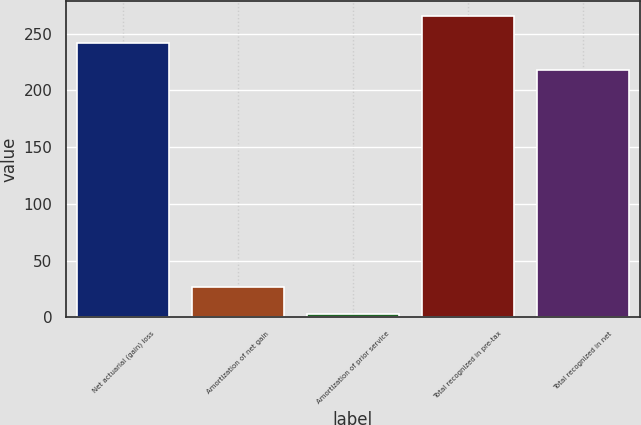<chart> <loc_0><loc_0><loc_500><loc_500><bar_chart><fcel>Net actuarial (gain) loss<fcel>Amortization of net gain<fcel>Amortization of prior service<fcel>Total recognized in pre-tax<fcel>Total recognized in net<nl><fcel>242.08<fcel>26.88<fcel>3.1<fcel>265.86<fcel>218.3<nl></chart> 